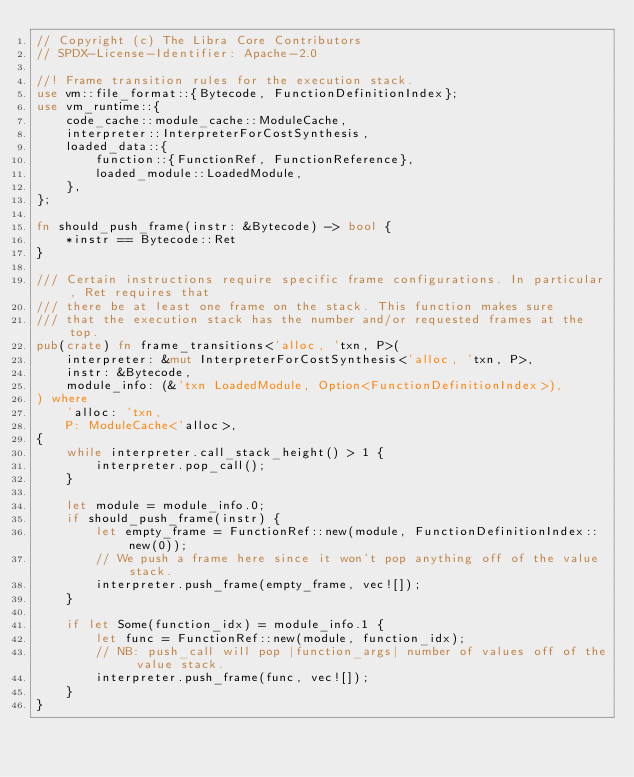<code> <loc_0><loc_0><loc_500><loc_500><_Rust_>// Copyright (c) The Libra Core Contributors
// SPDX-License-Identifier: Apache-2.0

//! Frame transition rules for the execution stack.
use vm::file_format::{Bytecode, FunctionDefinitionIndex};
use vm_runtime::{
    code_cache::module_cache::ModuleCache,
    interpreter::InterpreterForCostSynthesis,
    loaded_data::{
        function::{FunctionRef, FunctionReference},
        loaded_module::LoadedModule,
    },
};

fn should_push_frame(instr: &Bytecode) -> bool {
    *instr == Bytecode::Ret
}

/// Certain instructions require specific frame configurations. In particular, Ret requires that
/// there be at least one frame on the stack. This function makes sure
/// that the execution stack has the number and/or requested frames at the top.
pub(crate) fn frame_transitions<'alloc, 'txn, P>(
    interpreter: &mut InterpreterForCostSynthesis<'alloc, 'txn, P>,
    instr: &Bytecode,
    module_info: (&'txn LoadedModule, Option<FunctionDefinitionIndex>),
) where
    'alloc: 'txn,
    P: ModuleCache<'alloc>,
{
    while interpreter.call_stack_height() > 1 {
        interpreter.pop_call();
    }

    let module = module_info.0;
    if should_push_frame(instr) {
        let empty_frame = FunctionRef::new(module, FunctionDefinitionIndex::new(0));
        // We push a frame here since it won't pop anything off of the value stack.
        interpreter.push_frame(empty_frame, vec![]);
    }

    if let Some(function_idx) = module_info.1 {
        let func = FunctionRef::new(module, function_idx);
        // NB: push_call will pop |function_args| number of values off of the value stack.
        interpreter.push_frame(func, vec![]);
    }
}
</code> 